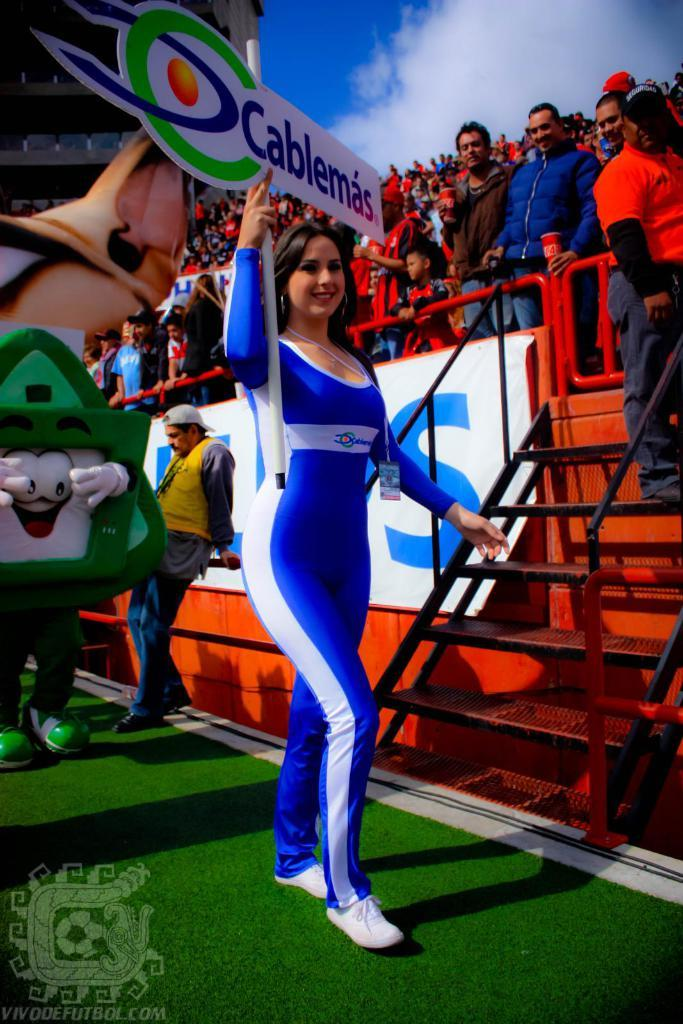<image>
Render a clear and concise summary of the photo. A woman walking across a field with a sign that says Cablemas on it. 